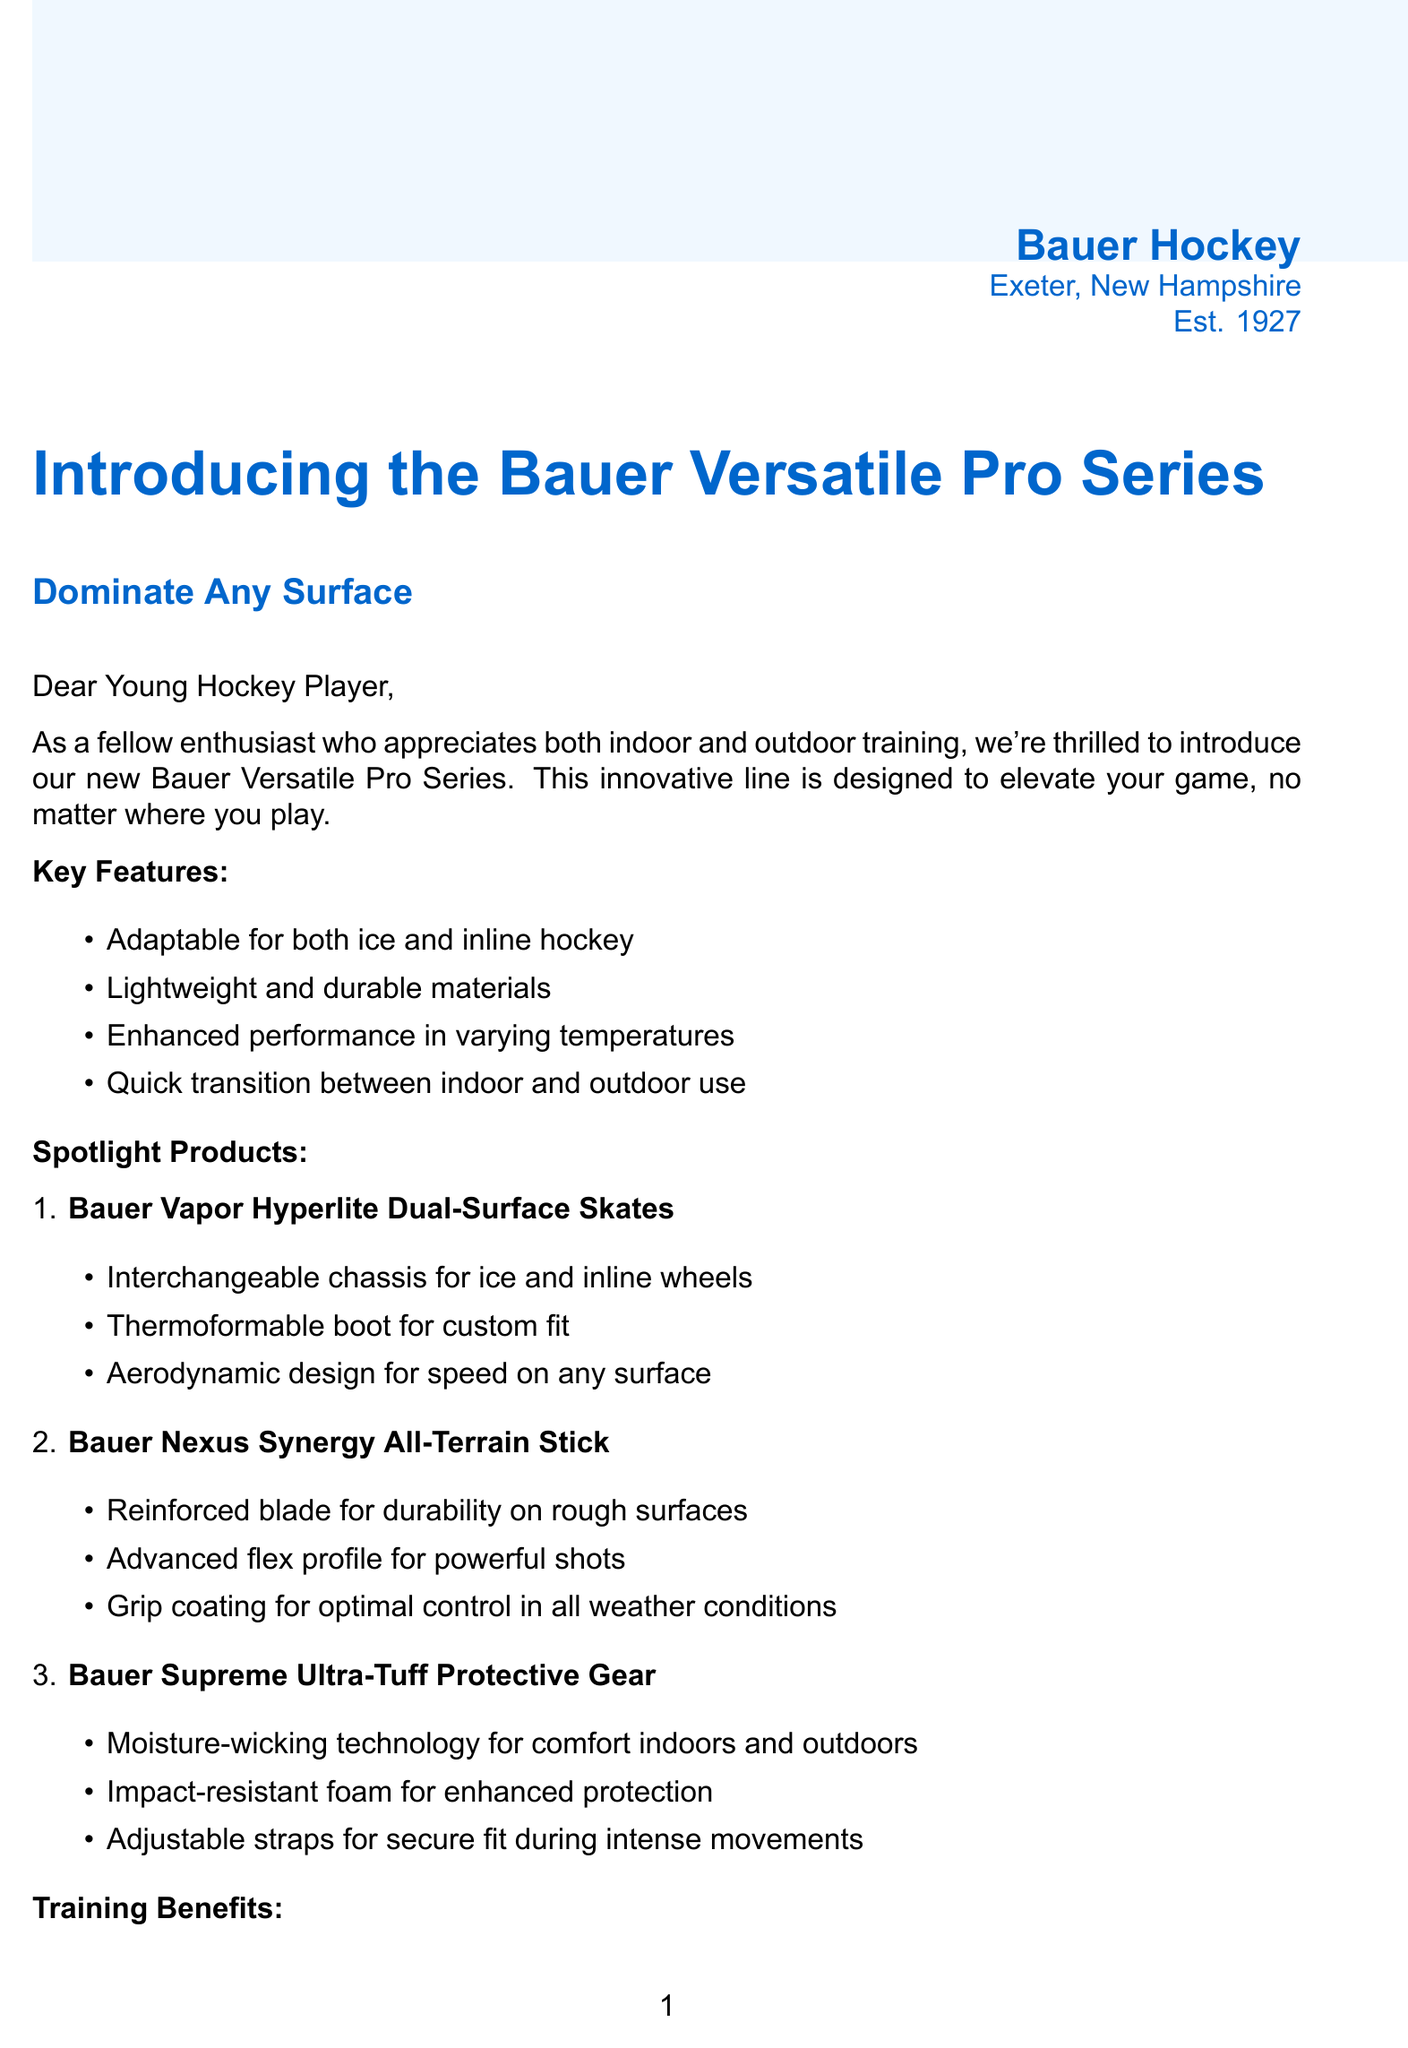What is the name of the new product line? The document introduces a new product line, which is mentioned in the heading as "Bauer Versatile Pro Series".
Answer: Bauer Versatile Pro Series When was Bauer Hockey established? The document includes the establishment year of Bauer Hockey in the company info section, which is 1927.
Answer: 1927 Who is the player that provided a testimonial? The document states that Connor McDavid, a player from the Edmonton Oilers, provided a testimonial about the product line.
Answer: Connor McDavid What is the discount offered for junior players? The document mentions a specific percentage discount for junior players, which is stated as 15%.
Answer: 15% What material is used for the packaging? The document describes the company's commitment to sustainability by stating that they use minimal plastic and recyclable materials for packaging.
Answer: Recyclable materials What are two key benefits of using the Bauer Versatile Pro Series gear? The document lists several training benefits, including improved adaptability to different playing surfaces and enhanced overall skill development.
Answer: Improved adaptability, enhanced skill development What is the special offer that includes a free item? The document specifies a special offer which includes a free gear bag with the purchase of a complete set.
Answer: Free gear bag What does the product line emphasize about performance? The key features section highlights that the gear has enhanced performance in varying temperatures, emphasizing versatility.
Answer: Enhanced performance in varying temperatures What is the customer service email provided? The document includes contact information, specifically the customer service email address for inquiries, which is support@bauerhockey.com.
Answer: support@bauerhockey.com 